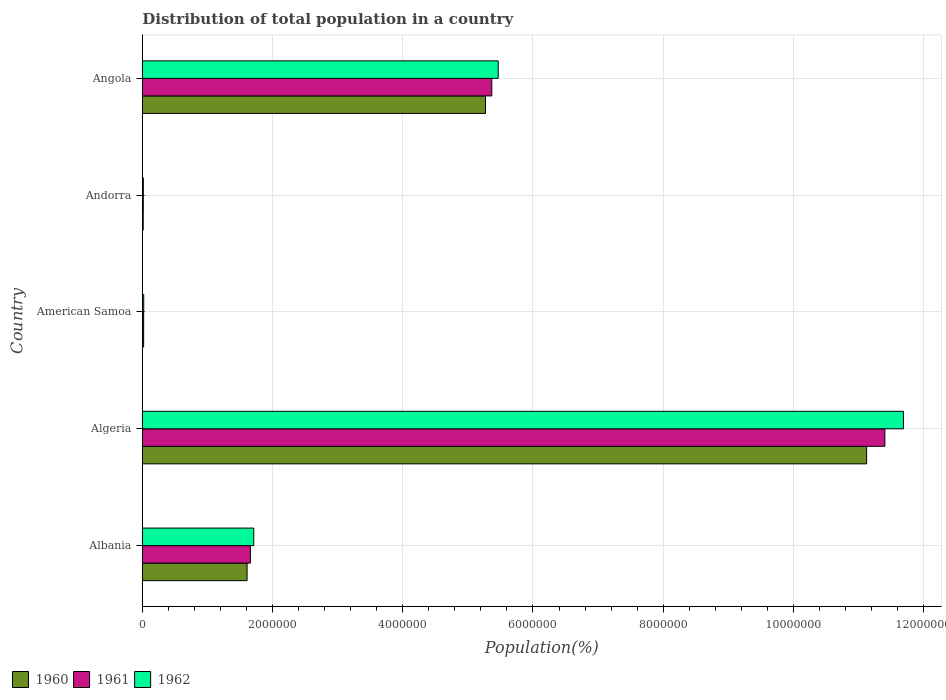How many groups of bars are there?
Offer a very short reply. 5. Are the number of bars on each tick of the Y-axis equal?
Keep it short and to the point. Yes. What is the label of the 1st group of bars from the top?
Provide a succinct answer. Angola. In how many cases, is the number of bars for a given country not equal to the number of legend labels?
Your response must be concise. 0. What is the population of in 1962 in Algeria?
Keep it short and to the point. 1.17e+07. Across all countries, what is the maximum population of in 1960?
Ensure brevity in your answer.  1.11e+07. Across all countries, what is the minimum population of in 1962?
Make the answer very short. 1.54e+04. In which country was the population of in 1960 maximum?
Offer a terse response. Algeria. In which country was the population of in 1962 minimum?
Provide a succinct answer. Andorra. What is the total population of in 1961 in the graph?
Give a very brief answer. 1.85e+07. What is the difference between the population of in 1962 in American Samoa and that in Andorra?
Provide a succinct answer. 5742. What is the difference between the population of in 1962 in Andorra and the population of in 1961 in Algeria?
Your answer should be very brief. -1.14e+07. What is the average population of in 1960 per country?
Your answer should be very brief. 3.61e+06. What is the difference between the population of in 1962 and population of in 1961 in Algeria?
Your answer should be very brief. 2.85e+05. What is the ratio of the population of in 1961 in Algeria to that in American Samoa?
Make the answer very short. 556.93. Is the difference between the population of in 1962 in Algeria and Angola greater than the difference between the population of in 1961 in Algeria and Angola?
Offer a very short reply. Yes. What is the difference between the highest and the second highest population of in 1960?
Provide a succinct answer. 5.85e+06. What is the difference between the highest and the lowest population of in 1961?
Keep it short and to the point. 1.14e+07. In how many countries, is the population of in 1960 greater than the average population of in 1960 taken over all countries?
Your response must be concise. 2. Is the sum of the population of in 1960 in Albania and American Samoa greater than the maximum population of in 1962 across all countries?
Provide a succinct answer. No. What does the 2nd bar from the top in Albania represents?
Keep it short and to the point. 1961. What does the 2nd bar from the bottom in Andorra represents?
Provide a short and direct response. 1961. Are all the bars in the graph horizontal?
Provide a short and direct response. Yes. Does the graph contain grids?
Your response must be concise. Yes. How many legend labels are there?
Provide a short and direct response. 3. How are the legend labels stacked?
Give a very brief answer. Horizontal. What is the title of the graph?
Make the answer very short. Distribution of total population in a country. Does "1991" appear as one of the legend labels in the graph?
Offer a very short reply. No. What is the label or title of the X-axis?
Make the answer very short. Population(%). What is the label or title of the Y-axis?
Your answer should be very brief. Country. What is the Population(%) in 1960 in Albania?
Provide a succinct answer. 1.61e+06. What is the Population(%) of 1961 in Albania?
Ensure brevity in your answer.  1.66e+06. What is the Population(%) in 1962 in Albania?
Keep it short and to the point. 1.71e+06. What is the Population(%) in 1960 in Algeria?
Ensure brevity in your answer.  1.11e+07. What is the Population(%) in 1961 in Algeria?
Your answer should be compact. 1.14e+07. What is the Population(%) in 1962 in Algeria?
Your answer should be compact. 1.17e+07. What is the Population(%) in 1960 in American Samoa?
Offer a very short reply. 2.00e+04. What is the Population(%) in 1961 in American Samoa?
Offer a very short reply. 2.05e+04. What is the Population(%) of 1962 in American Samoa?
Offer a very short reply. 2.11e+04. What is the Population(%) in 1960 in Andorra?
Provide a short and direct response. 1.34e+04. What is the Population(%) of 1961 in Andorra?
Your answer should be very brief. 1.44e+04. What is the Population(%) of 1962 in Andorra?
Your answer should be compact. 1.54e+04. What is the Population(%) in 1960 in Angola?
Provide a succinct answer. 5.27e+06. What is the Population(%) of 1961 in Angola?
Give a very brief answer. 5.37e+06. What is the Population(%) in 1962 in Angola?
Provide a succinct answer. 5.47e+06. Across all countries, what is the maximum Population(%) in 1960?
Provide a short and direct response. 1.11e+07. Across all countries, what is the maximum Population(%) of 1961?
Keep it short and to the point. 1.14e+07. Across all countries, what is the maximum Population(%) in 1962?
Provide a succinct answer. 1.17e+07. Across all countries, what is the minimum Population(%) in 1960?
Offer a terse response. 1.34e+04. Across all countries, what is the minimum Population(%) of 1961?
Your answer should be compact. 1.44e+04. Across all countries, what is the minimum Population(%) of 1962?
Your answer should be compact. 1.54e+04. What is the total Population(%) in 1960 in the graph?
Keep it short and to the point. 1.80e+07. What is the total Population(%) in 1961 in the graph?
Keep it short and to the point. 1.85e+07. What is the total Population(%) in 1962 in the graph?
Provide a short and direct response. 1.89e+07. What is the difference between the Population(%) of 1960 in Albania and that in Algeria?
Ensure brevity in your answer.  -9.52e+06. What is the difference between the Population(%) of 1961 in Albania and that in Algeria?
Keep it short and to the point. -9.75e+06. What is the difference between the Population(%) of 1962 in Albania and that in Algeria?
Keep it short and to the point. -9.98e+06. What is the difference between the Population(%) of 1960 in Albania and that in American Samoa?
Your answer should be compact. 1.59e+06. What is the difference between the Population(%) of 1961 in Albania and that in American Samoa?
Make the answer very short. 1.64e+06. What is the difference between the Population(%) of 1962 in Albania and that in American Samoa?
Your response must be concise. 1.69e+06. What is the difference between the Population(%) in 1960 in Albania and that in Andorra?
Your response must be concise. 1.60e+06. What is the difference between the Population(%) in 1961 in Albania and that in Andorra?
Ensure brevity in your answer.  1.65e+06. What is the difference between the Population(%) of 1962 in Albania and that in Andorra?
Keep it short and to the point. 1.70e+06. What is the difference between the Population(%) in 1960 in Albania and that in Angola?
Keep it short and to the point. -3.66e+06. What is the difference between the Population(%) in 1961 in Albania and that in Angola?
Offer a very short reply. -3.71e+06. What is the difference between the Population(%) of 1962 in Albania and that in Angola?
Ensure brevity in your answer.  -3.75e+06. What is the difference between the Population(%) in 1960 in Algeria and that in American Samoa?
Your answer should be very brief. 1.11e+07. What is the difference between the Population(%) in 1961 in Algeria and that in American Samoa?
Offer a very short reply. 1.14e+07. What is the difference between the Population(%) of 1962 in Algeria and that in American Samoa?
Your answer should be very brief. 1.17e+07. What is the difference between the Population(%) in 1960 in Algeria and that in Andorra?
Keep it short and to the point. 1.11e+07. What is the difference between the Population(%) of 1961 in Algeria and that in Andorra?
Your answer should be compact. 1.14e+07. What is the difference between the Population(%) in 1962 in Algeria and that in Andorra?
Make the answer very short. 1.17e+07. What is the difference between the Population(%) in 1960 in Algeria and that in Angola?
Your answer should be compact. 5.85e+06. What is the difference between the Population(%) of 1961 in Algeria and that in Angola?
Your answer should be very brief. 6.04e+06. What is the difference between the Population(%) of 1962 in Algeria and that in Angola?
Your answer should be very brief. 6.22e+06. What is the difference between the Population(%) of 1960 in American Samoa and that in Andorra?
Make the answer very short. 6598. What is the difference between the Population(%) in 1961 in American Samoa and that in Andorra?
Make the answer very short. 6102. What is the difference between the Population(%) in 1962 in American Samoa and that in Andorra?
Provide a succinct answer. 5742. What is the difference between the Population(%) of 1960 in American Samoa and that in Angola?
Give a very brief answer. -5.25e+06. What is the difference between the Population(%) in 1961 in American Samoa and that in Angola?
Keep it short and to the point. -5.35e+06. What is the difference between the Population(%) of 1962 in American Samoa and that in Angola?
Your response must be concise. -5.44e+06. What is the difference between the Population(%) in 1960 in Andorra and that in Angola?
Ensure brevity in your answer.  -5.26e+06. What is the difference between the Population(%) of 1961 in Andorra and that in Angola?
Your answer should be very brief. -5.35e+06. What is the difference between the Population(%) of 1962 in Andorra and that in Angola?
Your answer should be very brief. -5.45e+06. What is the difference between the Population(%) in 1960 in Albania and the Population(%) in 1961 in Algeria?
Provide a succinct answer. -9.80e+06. What is the difference between the Population(%) of 1960 in Albania and the Population(%) of 1962 in Algeria?
Provide a short and direct response. -1.01e+07. What is the difference between the Population(%) of 1961 in Albania and the Population(%) of 1962 in Algeria?
Keep it short and to the point. -1.00e+07. What is the difference between the Population(%) of 1960 in Albania and the Population(%) of 1961 in American Samoa?
Offer a terse response. 1.59e+06. What is the difference between the Population(%) of 1960 in Albania and the Population(%) of 1962 in American Samoa?
Make the answer very short. 1.59e+06. What is the difference between the Population(%) in 1961 in Albania and the Population(%) in 1962 in American Samoa?
Provide a short and direct response. 1.64e+06. What is the difference between the Population(%) of 1960 in Albania and the Population(%) of 1961 in Andorra?
Provide a short and direct response. 1.59e+06. What is the difference between the Population(%) in 1960 in Albania and the Population(%) in 1962 in Andorra?
Make the answer very short. 1.59e+06. What is the difference between the Population(%) of 1961 in Albania and the Population(%) of 1962 in Andorra?
Provide a succinct answer. 1.64e+06. What is the difference between the Population(%) in 1960 in Albania and the Population(%) in 1961 in Angola?
Make the answer very short. -3.76e+06. What is the difference between the Population(%) in 1960 in Albania and the Population(%) in 1962 in Angola?
Offer a terse response. -3.86e+06. What is the difference between the Population(%) in 1961 in Albania and the Population(%) in 1962 in Angola?
Provide a succinct answer. -3.81e+06. What is the difference between the Population(%) of 1960 in Algeria and the Population(%) of 1961 in American Samoa?
Offer a terse response. 1.11e+07. What is the difference between the Population(%) of 1960 in Algeria and the Population(%) of 1962 in American Samoa?
Offer a terse response. 1.11e+07. What is the difference between the Population(%) of 1961 in Algeria and the Population(%) of 1962 in American Samoa?
Make the answer very short. 1.14e+07. What is the difference between the Population(%) in 1960 in Algeria and the Population(%) in 1961 in Andorra?
Your answer should be compact. 1.11e+07. What is the difference between the Population(%) of 1960 in Algeria and the Population(%) of 1962 in Andorra?
Make the answer very short. 1.11e+07. What is the difference between the Population(%) in 1961 in Algeria and the Population(%) in 1962 in Andorra?
Your answer should be compact. 1.14e+07. What is the difference between the Population(%) of 1960 in Algeria and the Population(%) of 1961 in Angola?
Keep it short and to the point. 5.76e+06. What is the difference between the Population(%) of 1960 in Algeria and the Population(%) of 1962 in Angola?
Your answer should be compact. 5.66e+06. What is the difference between the Population(%) in 1961 in Algeria and the Population(%) in 1962 in Angola?
Offer a very short reply. 5.94e+06. What is the difference between the Population(%) in 1960 in American Samoa and the Population(%) in 1961 in Andorra?
Offer a very short reply. 5636. What is the difference between the Population(%) of 1960 in American Samoa and the Population(%) of 1962 in Andorra?
Provide a short and direct response. 4636. What is the difference between the Population(%) in 1961 in American Samoa and the Population(%) in 1962 in Andorra?
Your response must be concise. 5102. What is the difference between the Population(%) in 1960 in American Samoa and the Population(%) in 1961 in Angola?
Offer a terse response. -5.35e+06. What is the difference between the Population(%) in 1960 in American Samoa and the Population(%) in 1962 in Angola?
Give a very brief answer. -5.45e+06. What is the difference between the Population(%) of 1961 in American Samoa and the Population(%) of 1962 in Angola?
Your answer should be compact. -5.45e+06. What is the difference between the Population(%) in 1960 in Andorra and the Population(%) in 1961 in Angola?
Keep it short and to the point. -5.35e+06. What is the difference between the Population(%) in 1960 in Andorra and the Population(%) in 1962 in Angola?
Provide a succinct answer. -5.45e+06. What is the difference between the Population(%) in 1961 in Andorra and the Population(%) in 1962 in Angola?
Offer a very short reply. -5.45e+06. What is the average Population(%) of 1960 per country?
Give a very brief answer. 3.61e+06. What is the average Population(%) in 1961 per country?
Your answer should be compact. 3.69e+06. What is the average Population(%) of 1962 per country?
Your response must be concise. 3.78e+06. What is the difference between the Population(%) in 1960 and Population(%) in 1961 in Albania?
Offer a very short reply. -5.10e+04. What is the difference between the Population(%) of 1960 and Population(%) of 1962 in Albania?
Keep it short and to the point. -1.03e+05. What is the difference between the Population(%) of 1961 and Population(%) of 1962 in Albania?
Provide a short and direct response. -5.15e+04. What is the difference between the Population(%) in 1960 and Population(%) in 1961 in Algeria?
Provide a short and direct response. -2.80e+05. What is the difference between the Population(%) of 1960 and Population(%) of 1962 in Algeria?
Make the answer very short. -5.65e+05. What is the difference between the Population(%) of 1961 and Population(%) of 1962 in Algeria?
Offer a terse response. -2.85e+05. What is the difference between the Population(%) of 1960 and Population(%) of 1961 in American Samoa?
Keep it short and to the point. -466. What is the difference between the Population(%) in 1960 and Population(%) in 1962 in American Samoa?
Keep it short and to the point. -1106. What is the difference between the Population(%) of 1961 and Population(%) of 1962 in American Samoa?
Your answer should be compact. -640. What is the difference between the Population(%) in 1960 and Population(%) in 1961 in Andorra?
Make the answer very short. -962. What is the difference between the Population(%) of 1960 and Population(%) of 1962 in Andorra?
Provide a succinct answer. -1962. What is the difference between the Population(%) in 1961 and Population(%) in 1962 in Andorra?
Your answer should be compact. -1000. What is the difference between the Population(%) of 1960 and Population(%) of 1961 in Angola?
Offer a terse response. -9.64e+04. What is the difference between the Population(%) in 1960 and Population(%) in 1962 in Angola?
Ensure brevity in your answer.  -1.95e+05. What is the difference between the Population(%) in 1961 and Population(%) in 1962 in Angola?
Your answer should be very brief. -9.86e+04. What is the ratio of the Population(%) in 1960 in Albania to that in Algeria?
Offer a very short reply. 0.14. What is the ratio of the Population(%) of 1961 in Albania to that in Algeria?
Give a very brief answer. 0.15. What is the ratio of the Population(%) in 1962 in Albania to that in Algeria?
Give a very brief answer. 0.15. What is the ratio of the Population(%) of 1960 in Albania to that in American Samoa?
Ensure brevity in your answer.  80.39. What is the ratio of the Population(%) in 1961 in Albania to that in American Samoa?
Make the answer very short. 81.05. What is the ratio of the Population(%) of 1962 in Albania to that in American Samoa?
Offer a terse response. 81.04. What is the ratio of the Population(%) of 1960 in Albania to that in Andorra?
Provide a short and direct response. 119.93. What is the ratio of the Population(%) of 1961 in Albania to that in Andorra?
Offer a terse response. 115.46. What is the ratio of the Population(%) of 1962 in Albania to that in Andorra?
Provide a succinct answer. 111.3. What is the ratio of the Population(%) of 1960 in Albania to that in Angola?
Keep it short and to the point. 0.31. What is the ratio of the Population(%) in 1961 in Albania to that in Angola?
Provide a succinct answer. 0.31. What is the ratio of the Population(%) in 1962 in Albania to that in Angola?
Your answer should be compact. 0.31. What is the ratio of the Population(%) in 1960 in Algeria to that in American Samoa?
Provide a short and direct response. 555.91. What is the ratio of the Population(%) in 1961 in Algeria to that in American Samoa?
Offer a very short reply. 556.93. What is the ratio of the Population(%) of 1962 in Algeria to that in American Samoa?
Offer a terse response. 553.56. What is the ratio of the Population(%) of 1960 in Algeria to that in Andorra?
Offer a terse response. 829.35. What is the ratio of the Population(%) in 1961 in Algeria to that in Andorra?
Your answer should be compact. 793.33. What is the ratio of the Population(%) of 1962 in Algeria to that in Andorra?
Give a very brief answer. 760.29. What is the ratio of the Population(%) in 1960 in Algeria to that in Angola?
Your response must be concise. 2.11. What is the ratio of the Population(%) in 1961 in Algeria to that in Angola?
Provide a succinct answer. 2.12. What is the ratio of the Population(%) of 1962 in Algeria to that in Angola?
Make the answer very short. 2.14. What is the ratio of the Population(%) in 1960 in American Samoa to that in Andorra?
Provide a succinct answer. 1.49. What is the ratio of the Population(%) of 1961 in American Samoa to that in Andorra?
Provide a succinct answer. 1.42. What is the ratio of the Population(%) of 1962 in American Samoa to that in Andorra?
Offer a very short reply. 1.37. What is the ratio of the Population(%) of 1960 in American Samoa to that in Angola?
Ensure brevity in your answer.  0. What is the ratio of the Population(%) in 1961 in American Samoa to that in Angola?
Provide a short and direct response. 0. What is the ratio of the Population(%) in 1962 in American Samoa to that in Angola?
Offer a terse response. 0. What is the ratio of the Population(%) of 1960 in Andorra to that in Angola?
Give a very brief answer. 0. What is the ratio of the Population(%) in 1961 in Andorra to that in Angola?
Keep it short and to the point. 0. What is the ratio of the Population(%) of 1962 in Andorra to that in Angola?
Offer a terse response. 0. What is the difference between the highest and the second highest Population(%) of 1960?
Your response must be concise. 5.85e+06. What is the difference between the highest and the second highest Population(%) of 1961?
Make the answer very short. 6.04e+06. What is the difference between the highest and the second highest Population(%) in 1962?
Ensure brevity in your answer.  6.22e+06. What is the difference between the highest and the lowest Population(%) in 1960?
Make the answer very short. 1.11e+07. What is the difference between the highest and the lowest Population(%) in 1961?
Your answer should be compact. 1.14e+07. What is the difference between the highest and the lowest Population(%) in 1962?
Provide a succinct answer. 1.17e+07. 